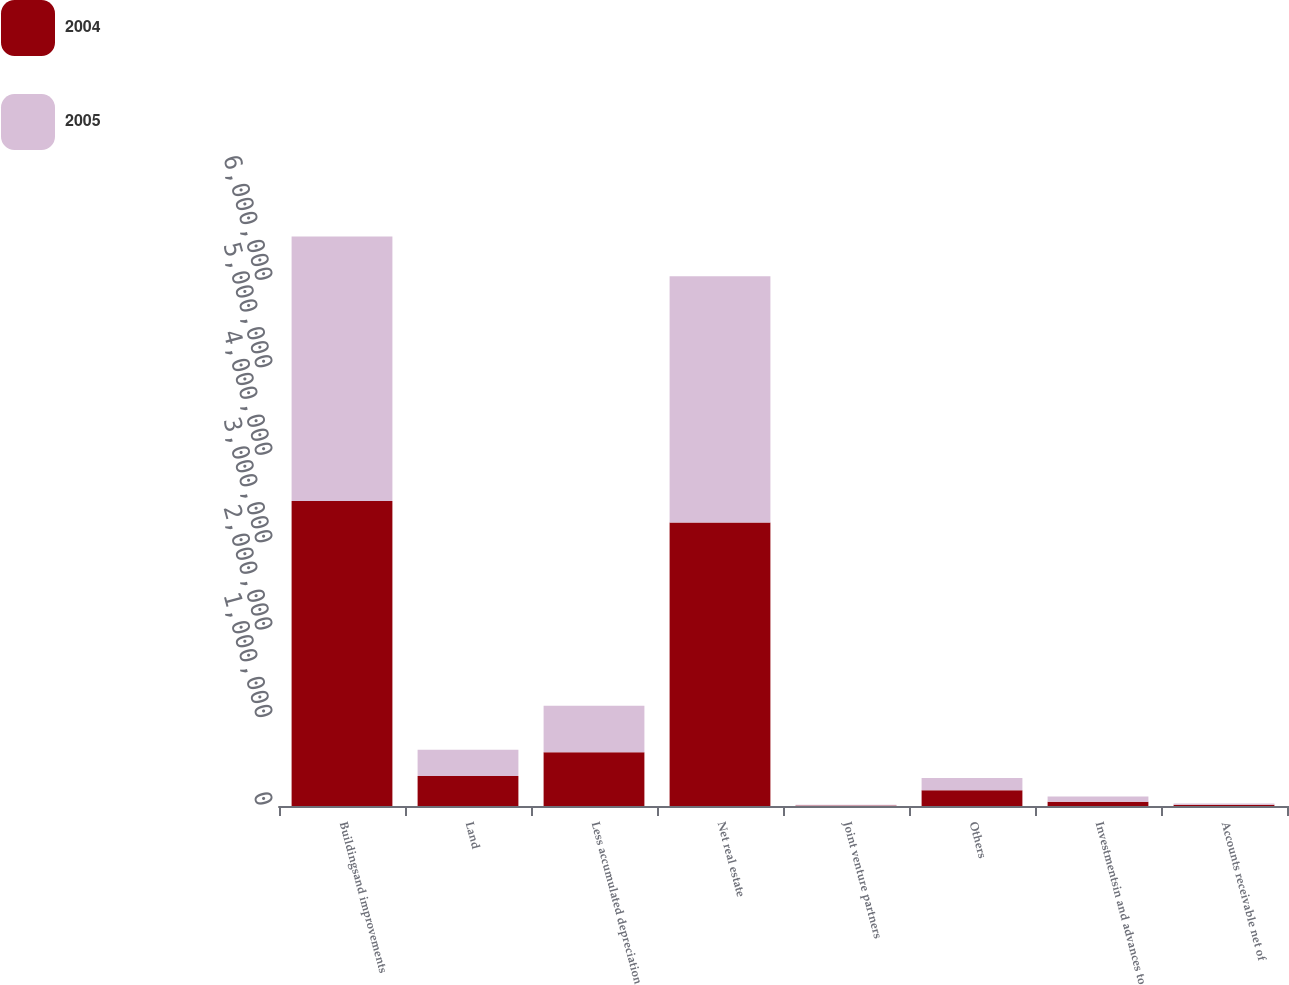Convert chart to OTSL. <chart><loc_0><loc_0><loc_500><loc_500><stacked_bar_chart><ecel><fcel>Buildingsand improvements<fcel>Land<fcel>Less accumulated depreciation<fcel>Net real estate<fcel>Joint venture partners<fcel>Others<fcel>Investmentsin and advances to<fcel>Accounts receivable net of<nl><fcel>2004<fcel>3.48942e+06<fcel>344240<fcel>614089<fcel>3.24185e+06<fcel>7006<fcel>179825<fcel>48598<fcel>13313<nl><fcel>2005<fcel>3.02571e+06<fcel>299461<fcel>533764<fcel>2.81718e+06<fcel>6473<fcel>139919<fcel>60506<fcel>14834<nl></chart> 